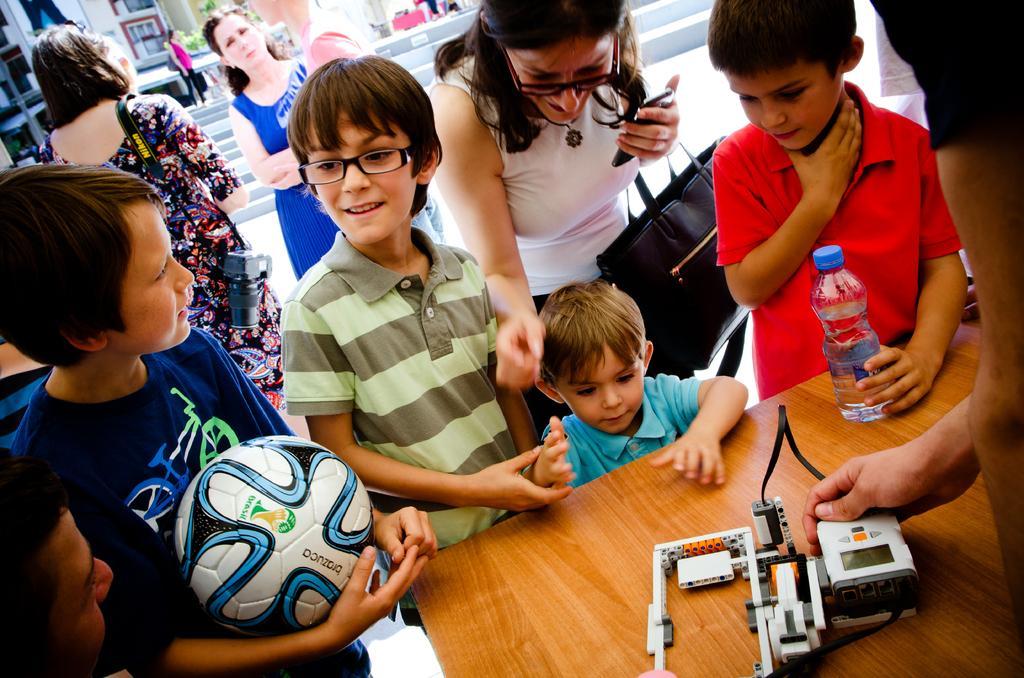How would you summarize this image in a sentence or two? This image is taken in outdoors. There are few kids and women in this image. In the right side of the image there is a table and a man standing near the table holding a thing in his hand and there is a water bottle on the table. In the left side of the image a boy is standing and holding a football in his hand. In the background there are few buildings with windows and doors and a woman is standing. 